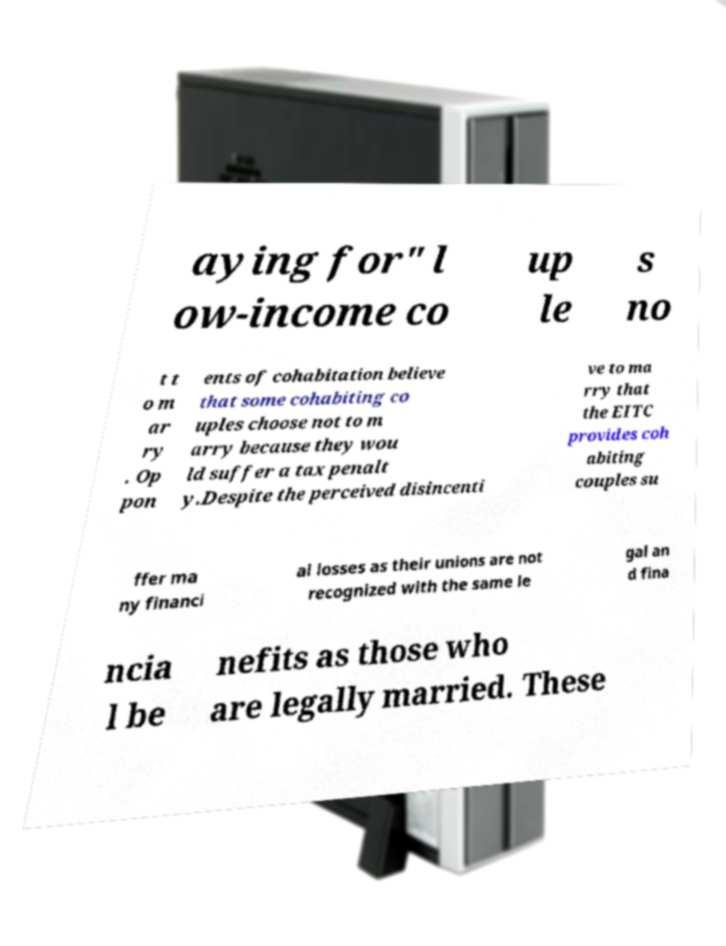Can you read and provide the text displayed in the image?This photo seems to have some interesting text. Can you extract and type it out for me? aying for" l ow-income co up le s no t t o m ar ry . Op pon ents of cohabitation believe that some cohabiting co uples choose not to m arry because they wou ld suffer a tax penalt y.Despite the perceived disincenti ve to ma rry that the EITC provides coh abiting couples su ffer ma ny financi al losses as their unions are not recognized with the same le gal an d fina ncia l be nefits as those who are legally married. These 